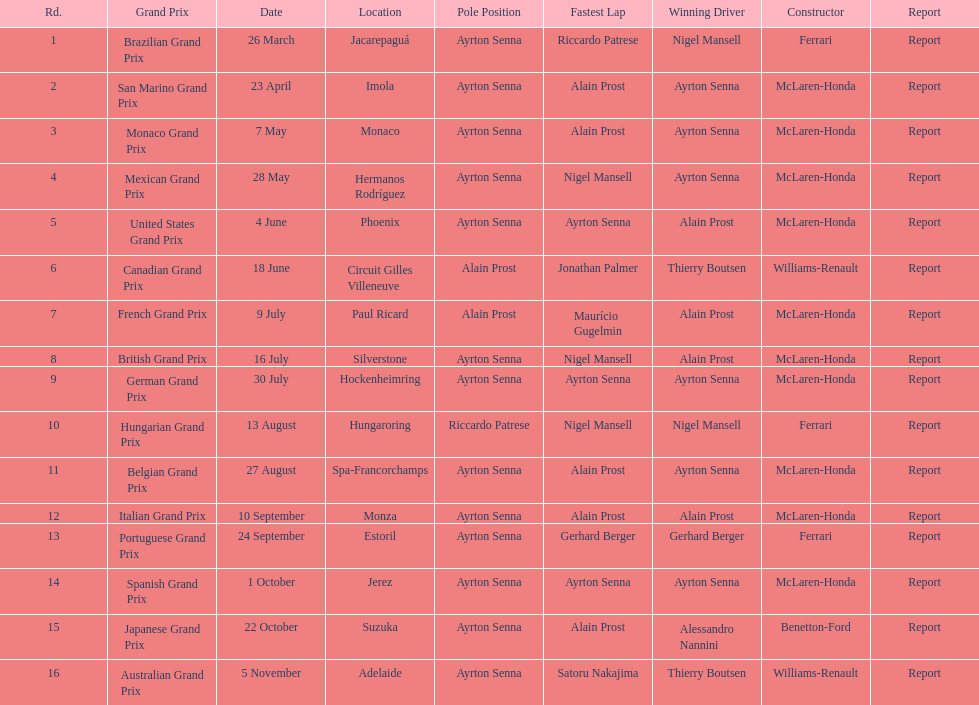Would you be able to parse every entry in this table? {'header': ['Rd.', 'Grand Prix', 'Date', 'Location', 'Pole Position', 'Fastest Lap', 'Winning Driver', 'Constructor', 'Report'], 'rows': [['1', 'Brazilian Grand Prix', '26 March', 'Jacarepaguá', 'Ayrton Senna', 'Riccardo Patrese', 'Nigel Mansell', 'Ferrari', 'Report'], ['2', 'San Marino Grand Prix', '23 April', 'Imola', 'Ayrton Senna', 'Alain Prost', 'Ayrton Senna', 'McLaren-Honda', 'Report'], ['3', 'Monaco Grand Prix', '7 May', 'Monaco', 'Ayrton Senna', 'Alain Prost', 'Ayrton Senna', 'McLaren-Honda', 'Report'], ['4', 'Mexican Grand Prix', '28 May', 'Hermanos Rodríguez', 'Ayrton Senna', 'Nigel Mansell', 'Ayrton Senna', 'McLaren-Honda', 'Report'], ['5', 'United States Grand Prix', '4 June', 'Phoenix', 'Ayrton Senna', 'Ayrton Senna', 'Alain Prost', 'McLaren-Honda', 'Report'], ['6', 'Canadian Grand Prix', '18 June', 'Circuit Gilles Villeneuve', 'Alain Prost', 'Jonathan Palmer', 'Thierry Boutsen', 'Williams-Renault', 'Report'], ['7', 'French Grand Prix', '9 July', 'Paul Ricard', 'Alain Prost', 'Maurício Gugelmin', 'Alain Prost', 'McLaren-Honda', 'Report'], ['8', 'British Grand Prix', '16 July', 'Silverstone', 'Ayrton Senna', 'Nigel Mansell', 'Alain Prost', 'McLaren-Honda', 'Report'], ['9', 'German Grand Prix', '30 July', 'Hockenheimring', 'Ayrton Senna', 'Ayrton Senna', 'Ayrton Senna', 'McLaren-Honda', 'Report'], ['10', 'Hungarian Grand Prix', '13 August', 'Hungaroring', 'Riccardo Patrese', 'Nigel Mansell', 'Nigel Mansell', 'Ferrari', 'Report'], ['11', 'Belgian Grand Prix', '27 August', 'Spa-Francorchamps', 'Ayrton Senna', 'Alain Prost', 'Ayrton Senna', 'McLaren-Honda', 'Report'], ['12', 'Italian Grand Prix', '10 September', 'Monza', 'Ayrton Senna', 'Alain Prost', 'Alain Prost', 'McLaren-Honda', 'Report'], ['13', 'Portuguese Grand Prix', '24 September', 'Estoril', 'Ayrton Senna', 'Gerhard Berger', 'Gerhard Berger', 'Ferrari', 'Report'], ['14', 'Spanish Grand Prix', '1 October', 'Jerez', 'Ayrton Senna', 'Ayrton Senna', 'Ayrton Senna', 'McLaren-Honda', 'Report'], ['15', 'Japanese Grand Prix', '22 October', 'Suzuka', 'Ayrton Senna', 'Alain Prost', 'Alessandro Nannini', 'Benetton-Ford', 'Report'], ['16', 'Australian Grand Prix', '5 November', 'Adelaide', 'Ayrton Senna', 'Satoru Nakajima', 'Thierry Boutsen', 'Williams-Renault', 'Report']]} How many did alain prost have the fastest lap? 5. 